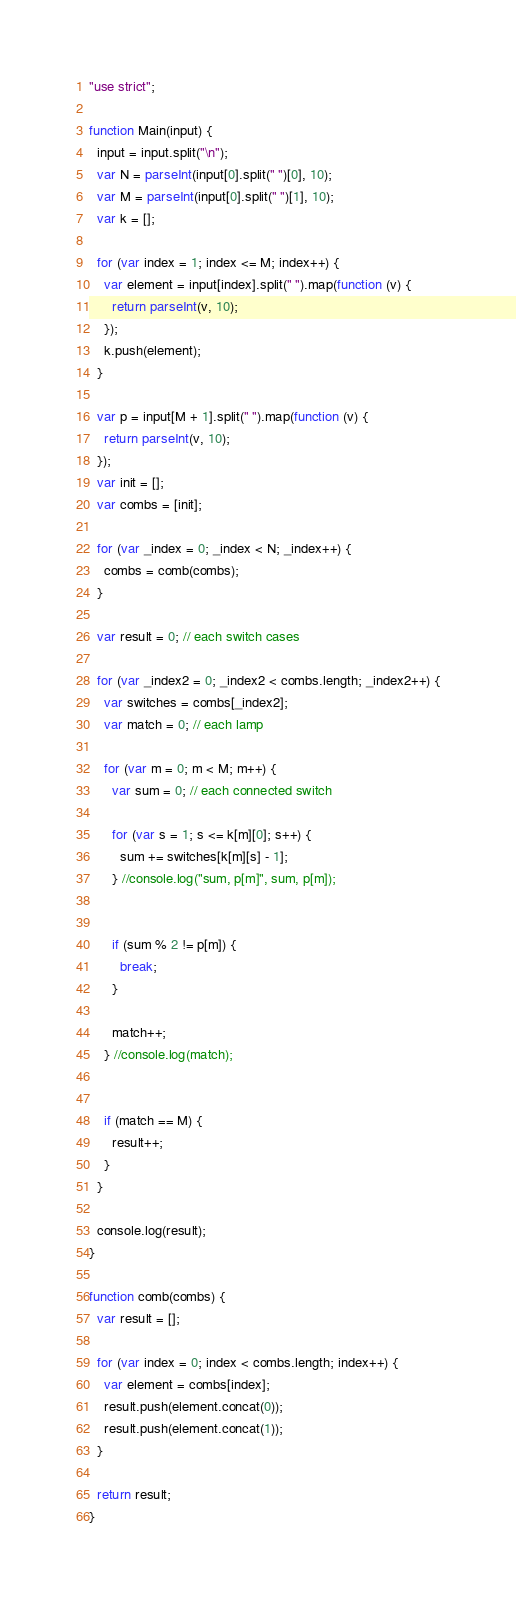<code> <loc_0><loc_0><loc_500><loc_500><_JavaScript_>"use strict";

function Main(input) {
  input = input.split("\n");
  var N = parseInt(input[0].split(" ")[0], 10);
  var M = parseInt(input[0].split(" ")[1], 10);
  var k = [];

  for (var index = 1; index <= M; index++) {
    var element = input[index].split(" ").map(function (v) {
      return parseInt(v, 10);
    });
    k.push(element);
  }

  var p = input[M + 1].split(" ").map(function (v) {
    return parseInt(v, 10);
  });
  var init = [];
  var combs = [init];

  for (var _index = 0; _index < N; _index++) {
    combs = comb(combs);
  }

  var result = 0; // each switch cases

  for (var _index2 = 0; _index2 < combs.length; _index2++) {
    var switches = combs[_index2];
    var match = 0; // each lamp        

    for (var m = 0; m < M; m++) {
      var sum = 0; // each connected switch

      for (var s = 1; s <= k[m][0]; s++) {
        sum += switches[k[m][s] - 1];
      } //console.log("sum, p[m]", sum, p[m]);


      if (sum % 2 != p[m]) {
        break;
      }

      match++;
    } //console.log(match);


    if (match == M) {
      result++;
    }
  }

  console.log(result);
}

function comb(combs) {
  var result = [];

  for (var index = 0; index < combs.length; index++) {
    var element = combs[index];
    result.push(element.concat(0));
    result.push(element.concat(1));
  }

  return result;
}</code> 